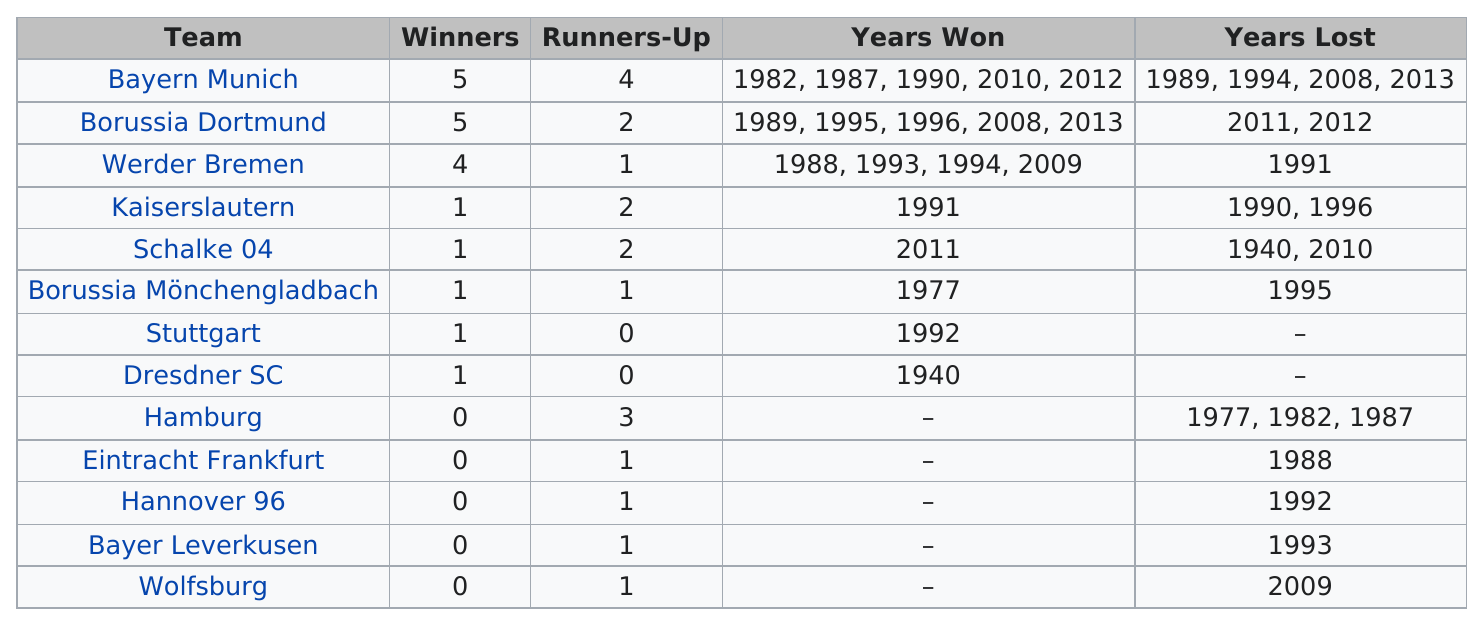Indicate a few pertinent items in this graphic. The teams that won five titles in total were Bayern Munich and Borussia Dortmund. Bayern Munich had the most runners-up in their team history. There are several teams that have won more matches than Werder Bremen, including Borussia Dortmund and Bayern Munich. Bayern Munich and Borussia Dortmund are tied for the most winners of the Bundesliga, with both teams having won the league a total of 7 times. Bayern Munich, Borussia Dortmund, and Werder Bremen are teams that have won the title at least twice. 